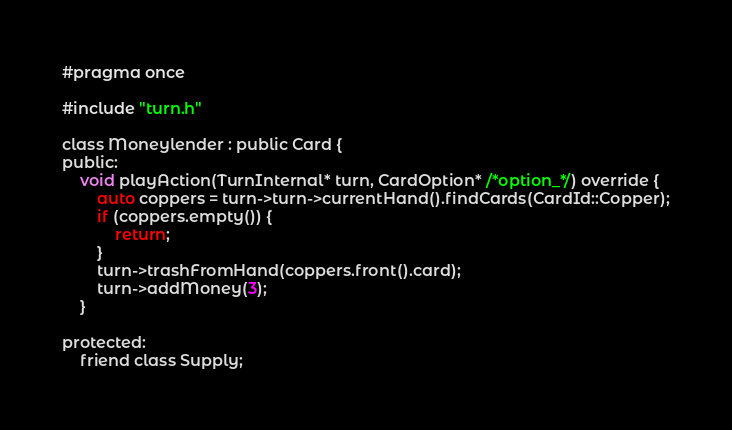Convert code to text. <code><loc_0><loc_0><loc_500><loc_500><_C_>#pragma once

#include "turn.h"

class Moneylender : public Card {
public:
    void playAction(TurnInternal* turn, CardOption* /*option_*/) override {
        auto coppers = turn->turn->currentHand().findCards(CardId::Copper);
        if (coppers.empty()) {
            return;
        }
        turn->trashFromHand(coppers.front().card);
        turn->addMoney(3);
    }

protected:
    friend class Supply;</code> 